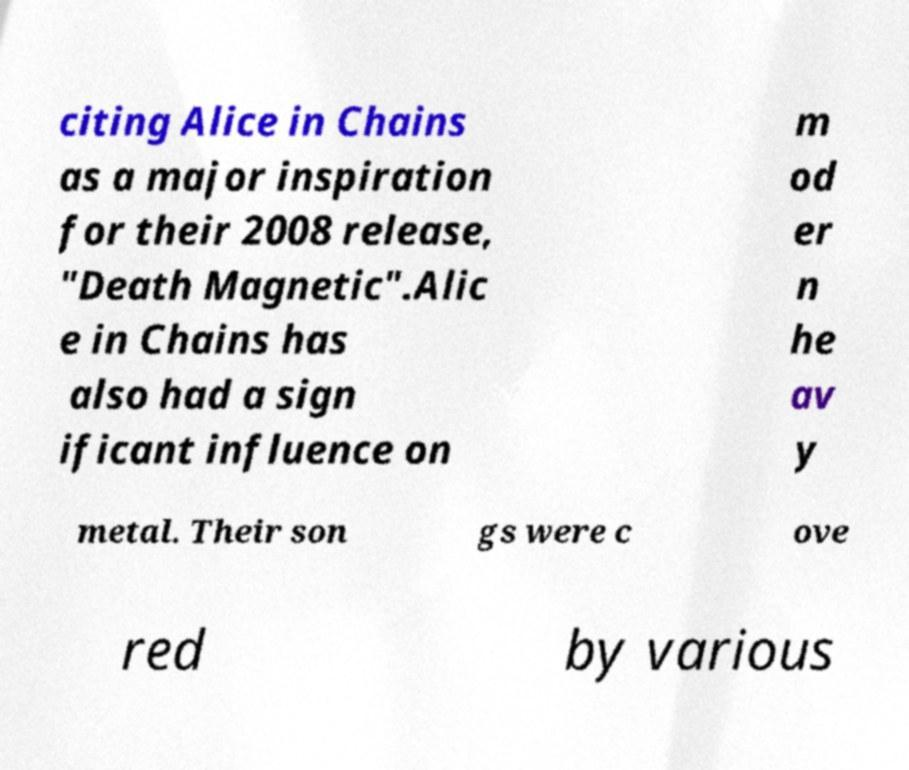Please read and relay the text visible in this image. What does it say? citing Alice in Chains as a major inspiration for their 2008 release, "Death Magnetic".Alic e in Chains has also had a sign ificant influence on m od er n he av y metal. Their son gs were c ove red by various 